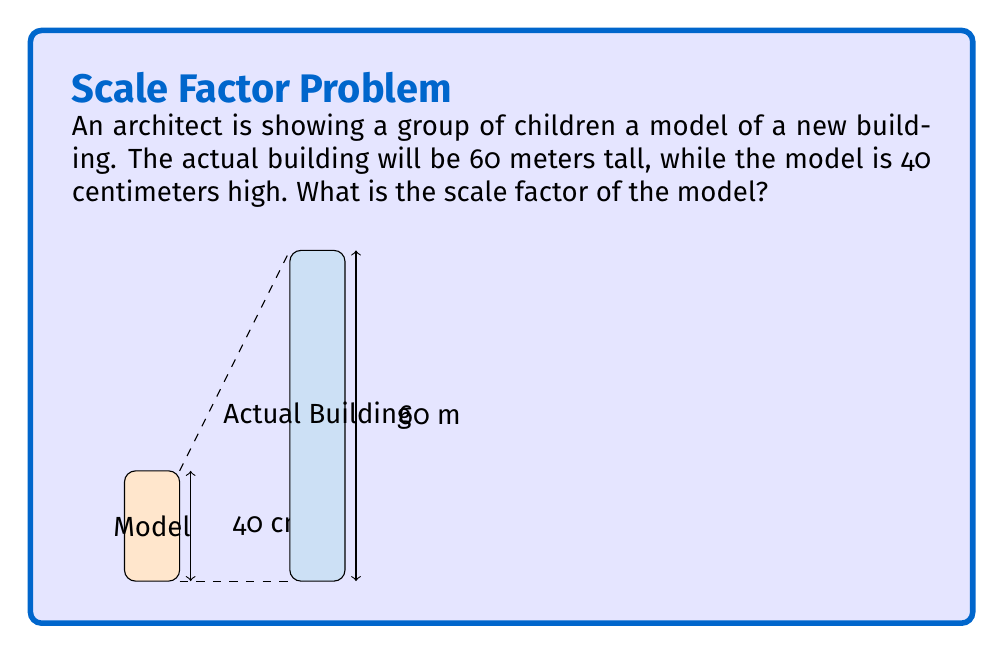Give your solution to this math problem. To determine the scale factor, we need to compare the size of the model to the actual size of the building. Let's follow these steps:

1) First, we need to convert both measurements to the same unit. Let's convert meters to centimeters:
   60 meters = 6000 centimeters

2) Now we can set up the ratio of the model size to the actual size:
   $\frac{\text{Model size}}{\text{Actual size}} = \frac{40 \text{ cm}}{6000 \text{ cm}}$

3) To simplify this fraction, we can divide both numerator and denominator by their greatest common divisor (GCD). The GCD of 40 and 6000 is 20:
   $\frac{40 \div 20}{6000 \div 20} = \frac{2}{300}$

4) This fraction $\frac{2}{300}$ represents the scale factor. It can be interpreted as "2 units on the model represent 300 units in reality".

5) To express this as a ratio in the form 1:x, we divide both sides by 2:
   $\frac{1}{150}$ or 1:150

Therefore, the scale factor is 1:150, meaning 1 unit on the model represents 150 units in reality.
Answer: 1:150 